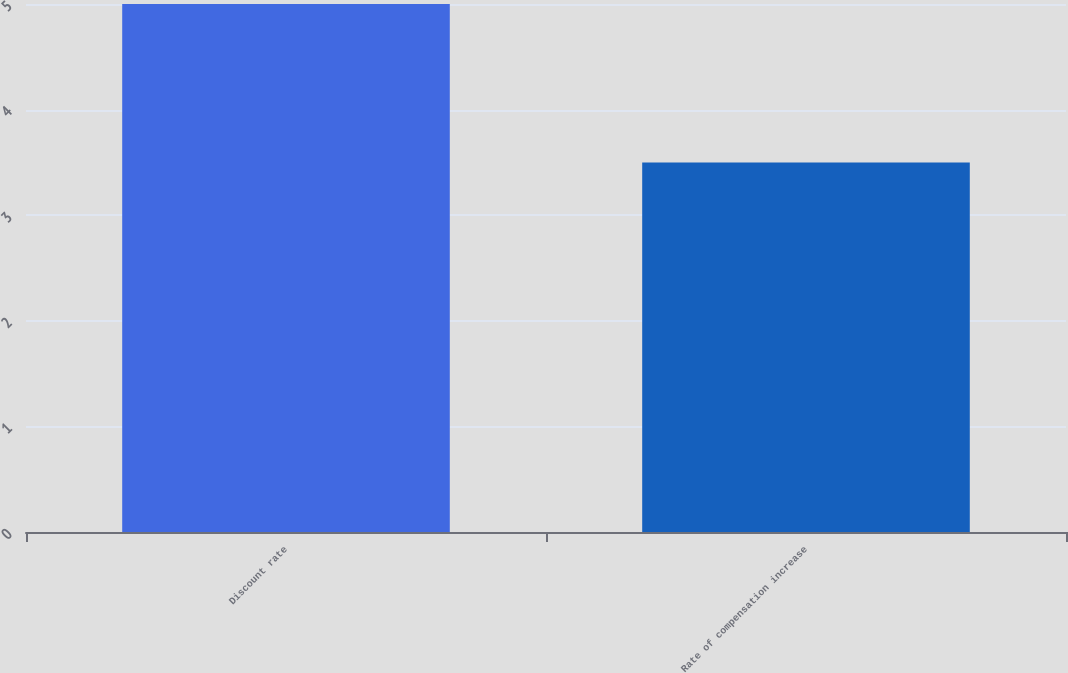Convert chart. <chart><loc_0><loc_0><loc_500><loc_500><bar_chart><fcel>Discount rate<fcel>Rate of compensation increase<nl><fcel>5<fcel>3.5<nl></chart> 